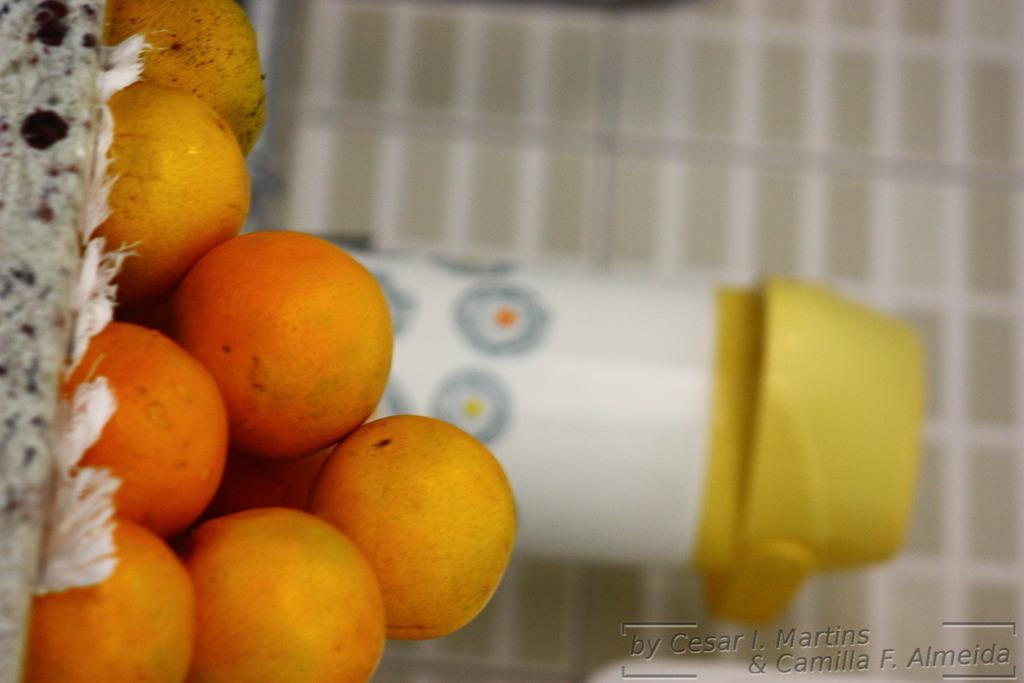Could you give a brief overview of what you see in this image? In this image we can see oranges and a bottle. In the background there is a wall. 